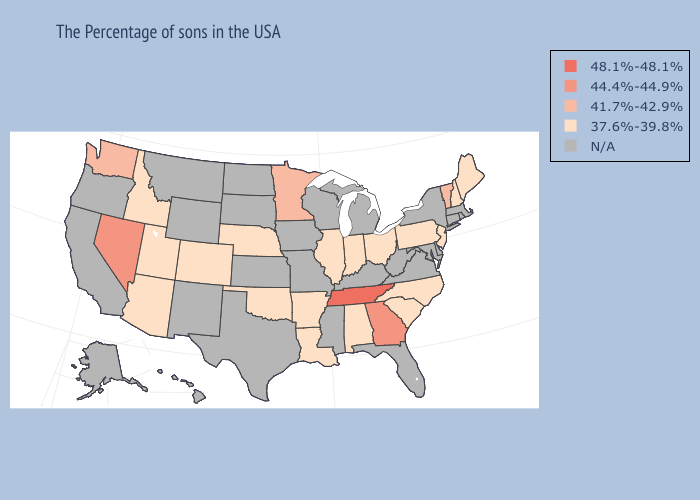What is the lowest value in states that border Delaware?
Answer briefly. 37.6%-39.8%. Name the states that have a value in the range N/A?
Answer briefly. Massachusetts, Rhode Island, Connecticut, New York, Delaware, Maryland, Virginia, West Virginia, Florida, Michigan, Kentucky, Wisconsin, Mississippi, Missouri, Iowa, Kansas, Texas, South Dakota, North Dakota, Wyoming, New Mexico, Montana, California, Oregon, Alaska, Hawaii. What is the highest value in states that border Oregon?
Answer briefly. 44.4%-44.9%. Name the states that have a value in the range 44.4%-44.9%?
Be succinct. Georgia, Nevada. What is the value of Illinois?
Concise answer only. 37.6%-39.8%. What is the lowest value in the Northeast?
Short answer required. 37.6%-39.8%. What is the lowest value in the MidWest?
Write a very short answer. 37.6%-39.8%. Does the first symbol in the legend represent the smallest category?
Short answer required. No. What is the value of Arizona?
Write a very short answer. 37.6%-39.8%. What is the highest value in the USA?
Answer briefly. 48.1%-48.1%. What is the value of Connecticut?
Write a very short answer. N/A. What is the value of New Hampshire?
Keep it brief. 37.6%-39.8%. What is the highest value in states that border Missouri?
Keep it brief. 48.1%-48.1%. Among the states that border Oregon , which have the lowest value?
Answer briefly. Idaho. 